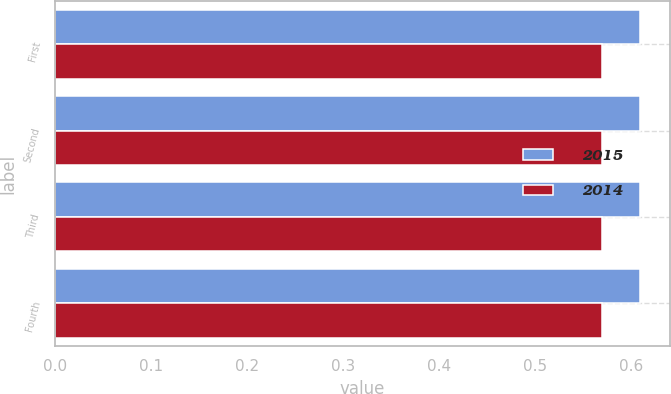Convert chart to OTSL. <chart><loc_0><loc_0><loc_500><loc_500><stacked_bar_chart><ecel><fcel>First<fcel>Second<fcel>Third<fcel>Fourth<nl><fcel>2015<fcel>0.61<fcel>0.61<fcel>0.61<fcel>0.61<nl><fcel>2014<fcel>0.57<fcel>0.57<fcel>0.57<fcel>0.57<nl></chart> 